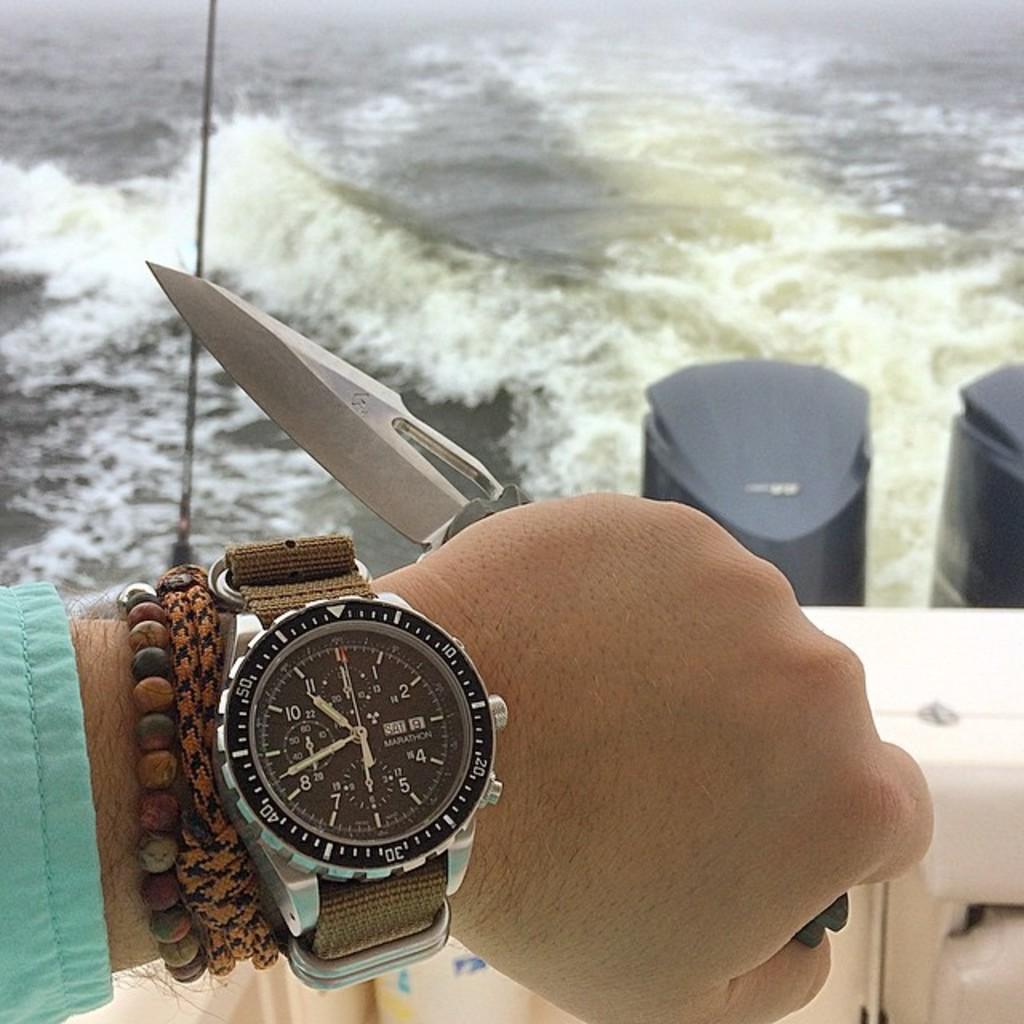What time does the watch say?
Provide a succinct answer. 10:42. 